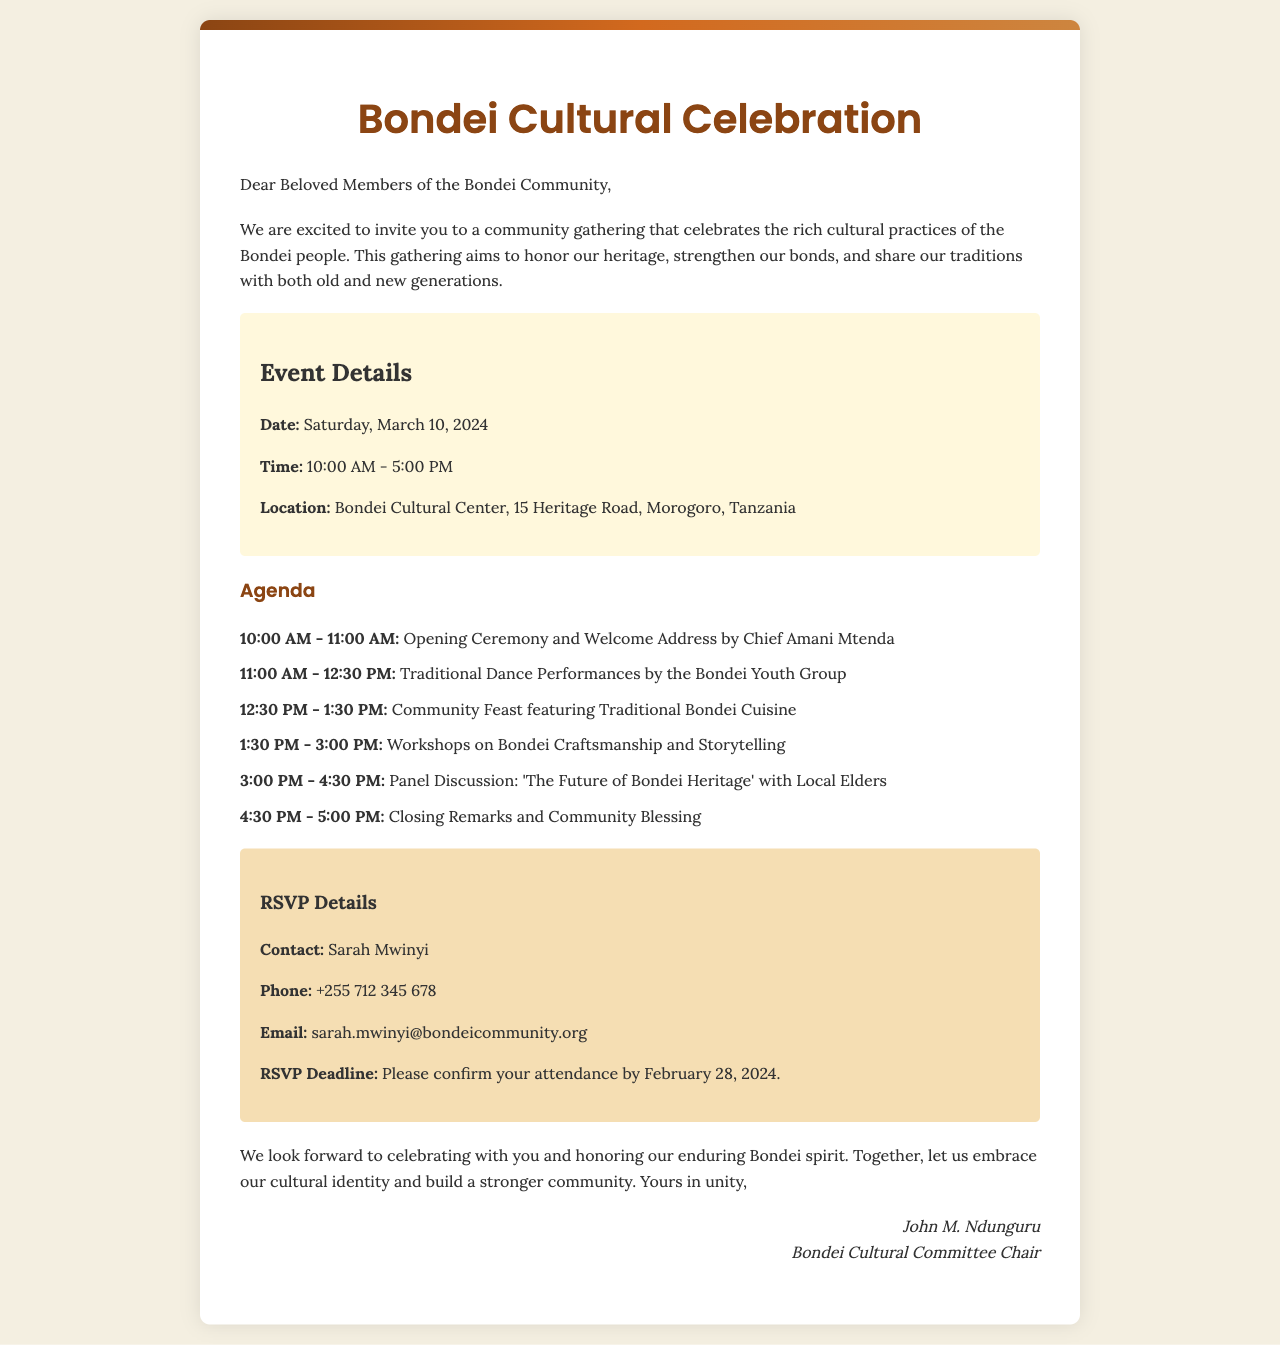What is the date of the gathering? The date of the gathering is specified in the event details section of the document.
Answer: Saturday, March 10, 2024 Who is giving the welcome address? The welcome address is mentioned as being given by a specific person at the opening ceremony in the agenda.
Answer: Chief Amani Mtenda What time does the gathering start? The starting time of the gathering is given in the event details section.
Answer: 10:00 AM What is the RSVP deadline? The RSVP deadline is mentioned in the RSVP details section of the document.
Answer: February 28, 2024 What will be featured during the community feast? The community feast section indicates what type of cuisine will be served, listed in the agenda.
Answer: Traditional Bondei Cuisine How long is the panel discussion scheduled to last? The duration of the panel discussion can be calculated based on the agenda times provided.
Answer: 1 hour 30 minutes What is the contact person's name for RSVPs? The RSVP details provide a specific individual's name for contact regarding attendance confirmation.
Answer: Sarah Mwinyi What is one of the workshop topics offered? The agenda lists specific topics for workshops that will take place during the gathering.
Answer: Bondei Craftsmanship 